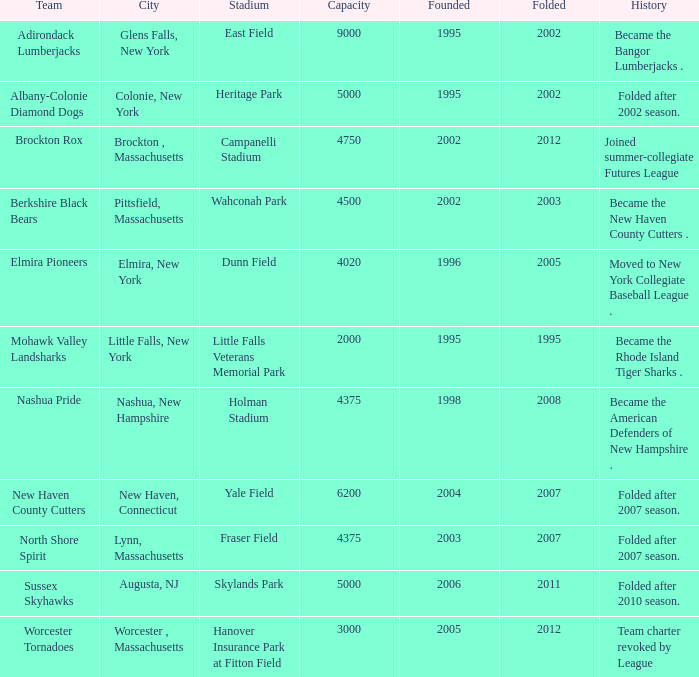What is the maximum folded value of the team whose stadium is Fraser Field? 2007.0. 